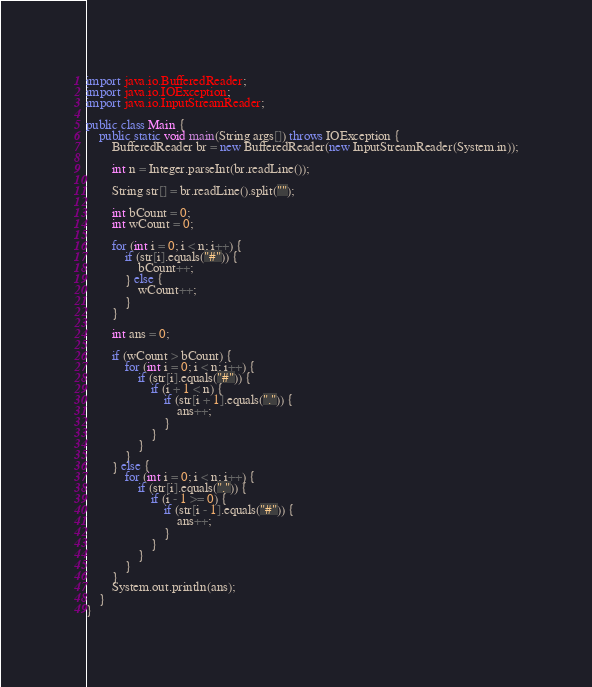Convert code to text. <code><loc_0><loc_0><loc_500><loc_500><_Java_>import java.io.BufferedReader;
import java.io.IOException;
import java.io.InputStreamReader;

public class Main {
	public static void main(String args[]) throws IOException {
		BufferedReader br = new BufferedReader(new InputStreamReader(System.in));

		int n = Integer.parseInt(br.readLine());

		String str[] = br.readLine().split("");

		int bCount = 0;
		int wCount = 0;

		for (int i = 0; i < n; i++) {
			if (str[i].equals("#")) {
				bCount++;
			} else {
				wCount++;
			}
		}

		int ans = 0;

		if (wCount > bCount) {
			for (int i = 0; i < n; i++) {
				if (str[i].equals("#")) {
					if (i + 1 < n) {
						if (str[i + 1].equals(".")) {
							ans++;
						}
					}
				}
			}
		} else {
			for (int i = 0; i < n; i++) {
				if (str[i].equals(".")) {
					if (i - 1 >= 0) {
						if (str[i - 1].equals("#")) {
							ans++;
						}
					}
				}
			}
		}
		System.out.println(ans);
	}
}
</code> 